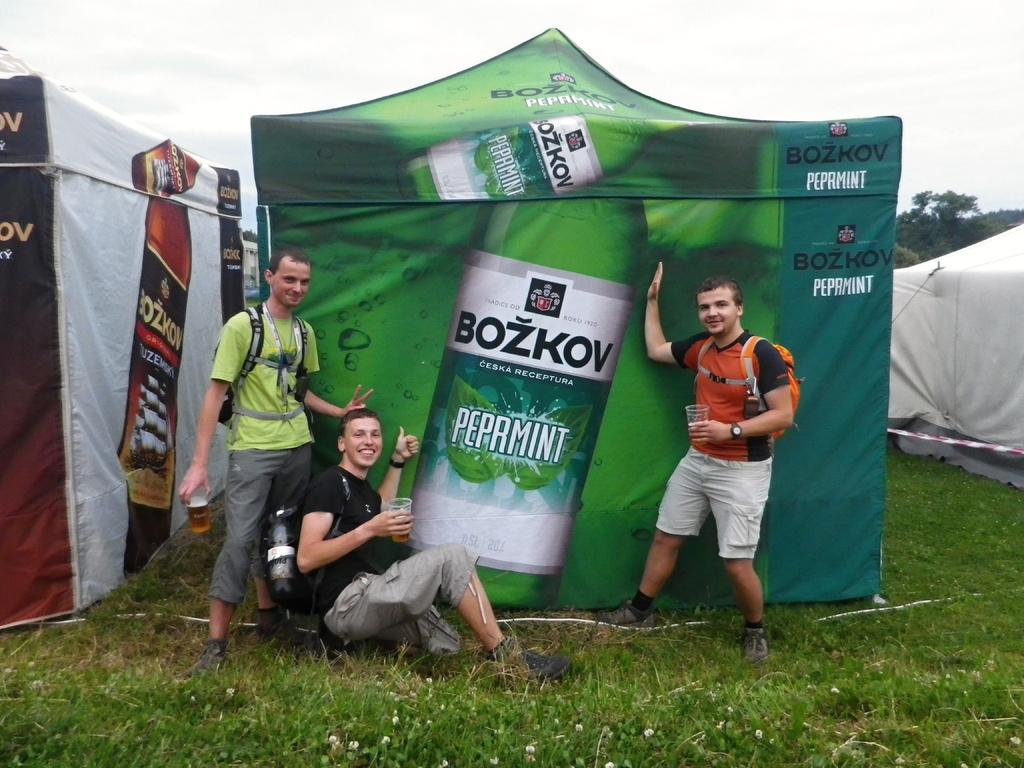How many people are in the image? There are three persons in the image. What are the persons holding in their hands? The persons are holding glasses in their hands. What type of natural environment is visible in the image? There is grass, trees, and the sky visible in the image. What type of temporary shelter can be seen in the image? There are tents in the image. What type of duck can be seen swimming in the stomach of one of the persons in the image? There is no duck present in the image, let alone swimming in someone's stomach. 